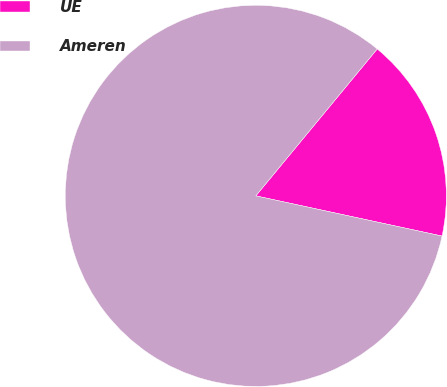<chart> <loc_0><loc_0><loc_500><loc_500><pie_chart><fcel>UE<fcel>Ameren<nl><fcel>17.39%<fcel>82.61%<nl></chart> 